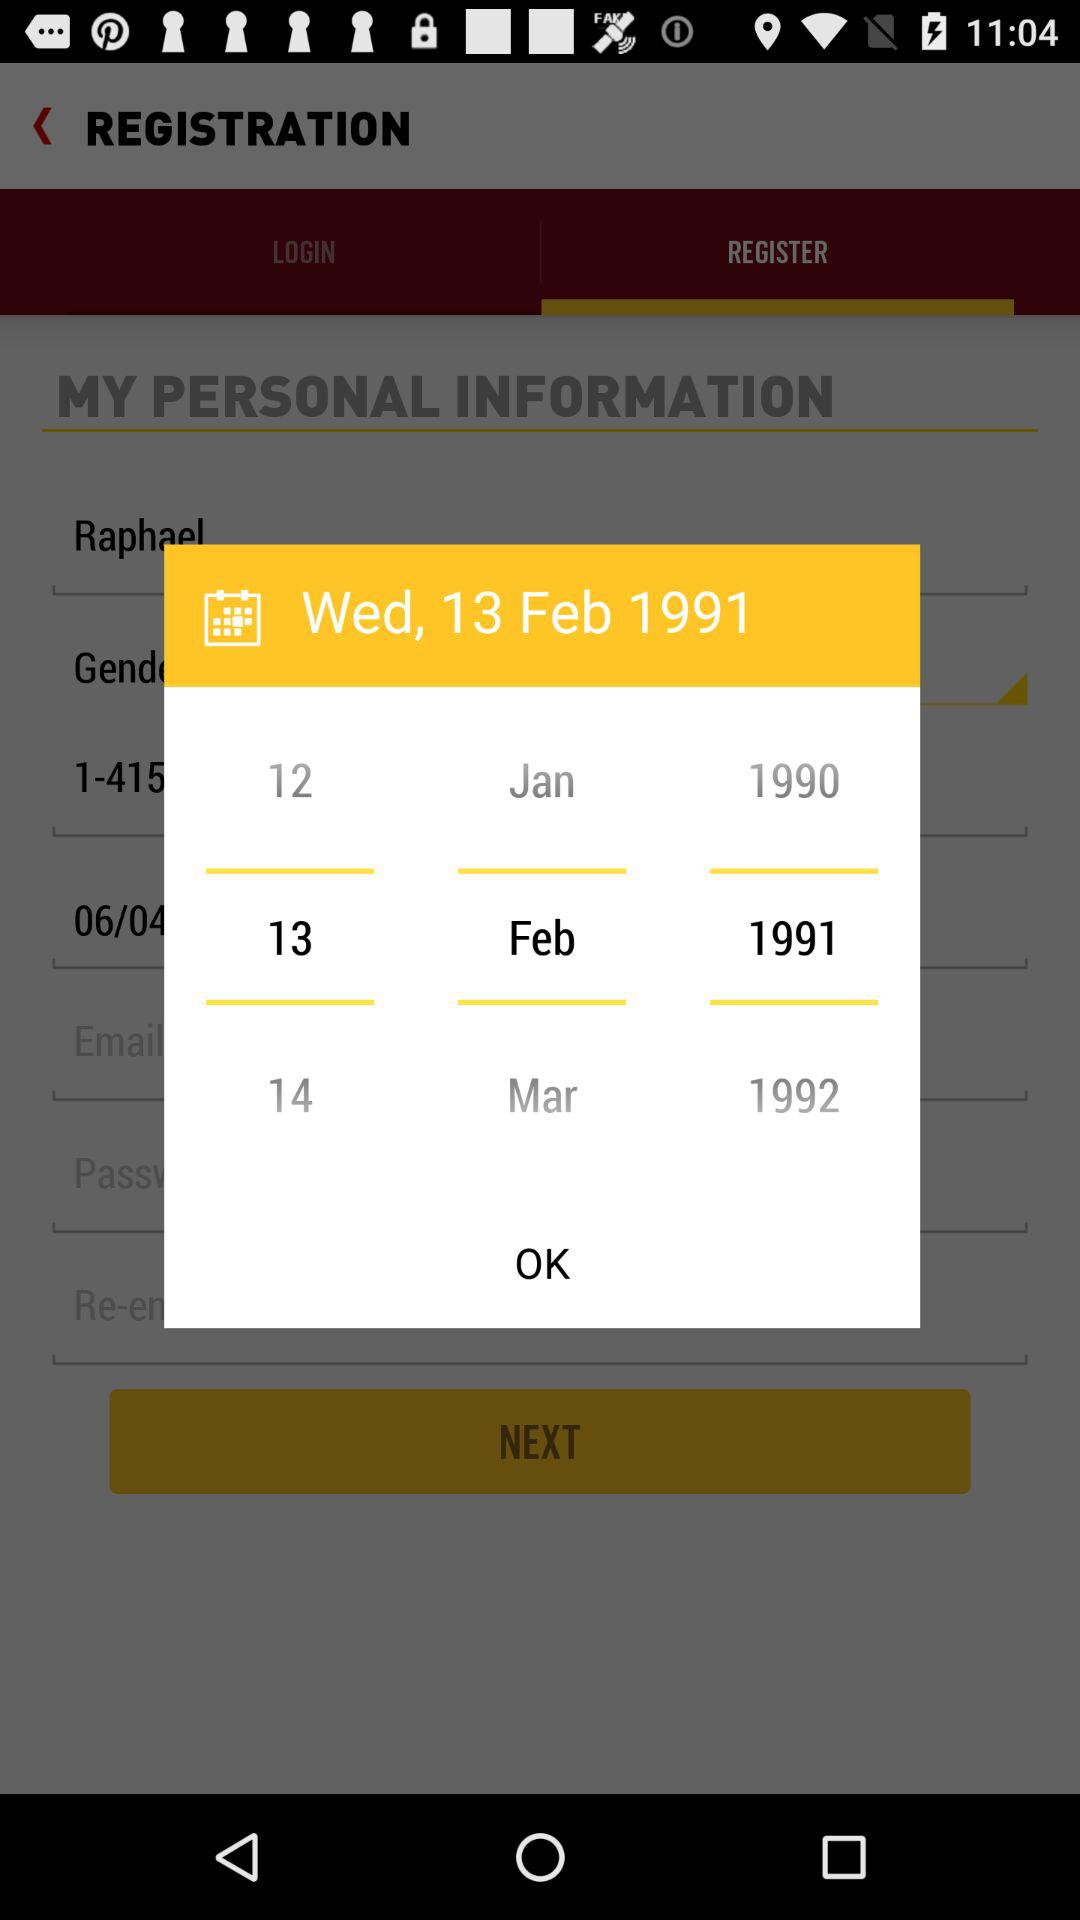How many months are shown on the calendar?
Answer the question using a single word or phrase. 3 